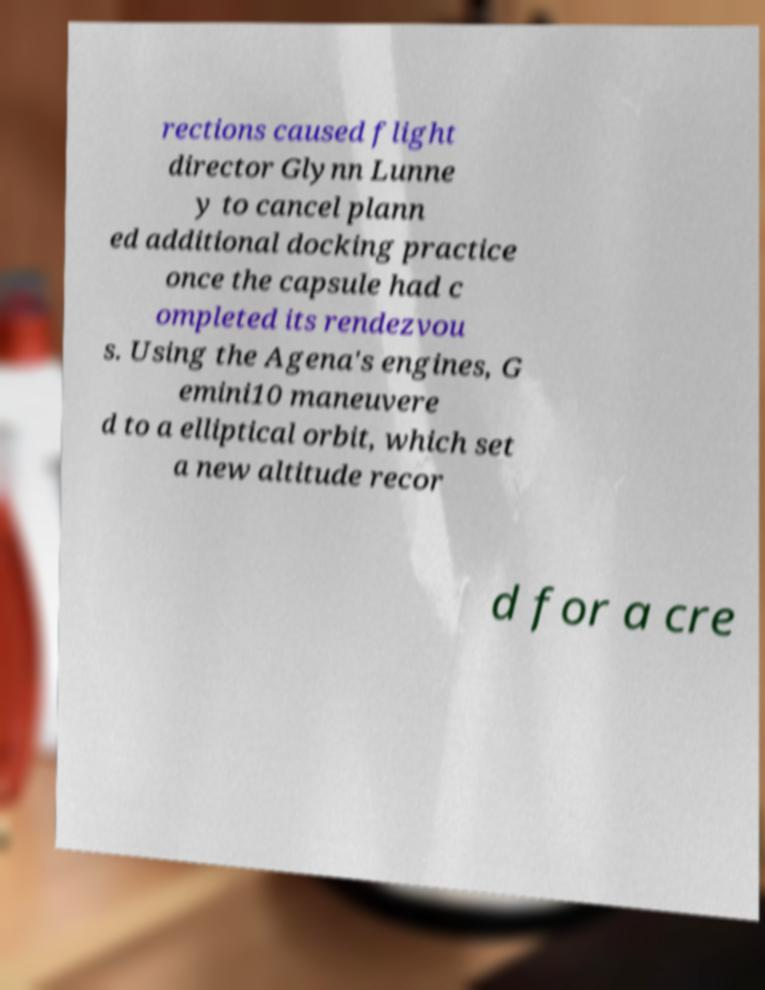There's text embedded in this image that I need extracted. Can you transcribe it verbatim? rections caused flight director Glynn Lunne y to cancel plann ed additional docking practice once the capsule had c ompleted its rendezvou s. Using the Agena's engines, G emini10 maneuvere d to a elliptical orbit, which set a new altitude recor d for a cre 